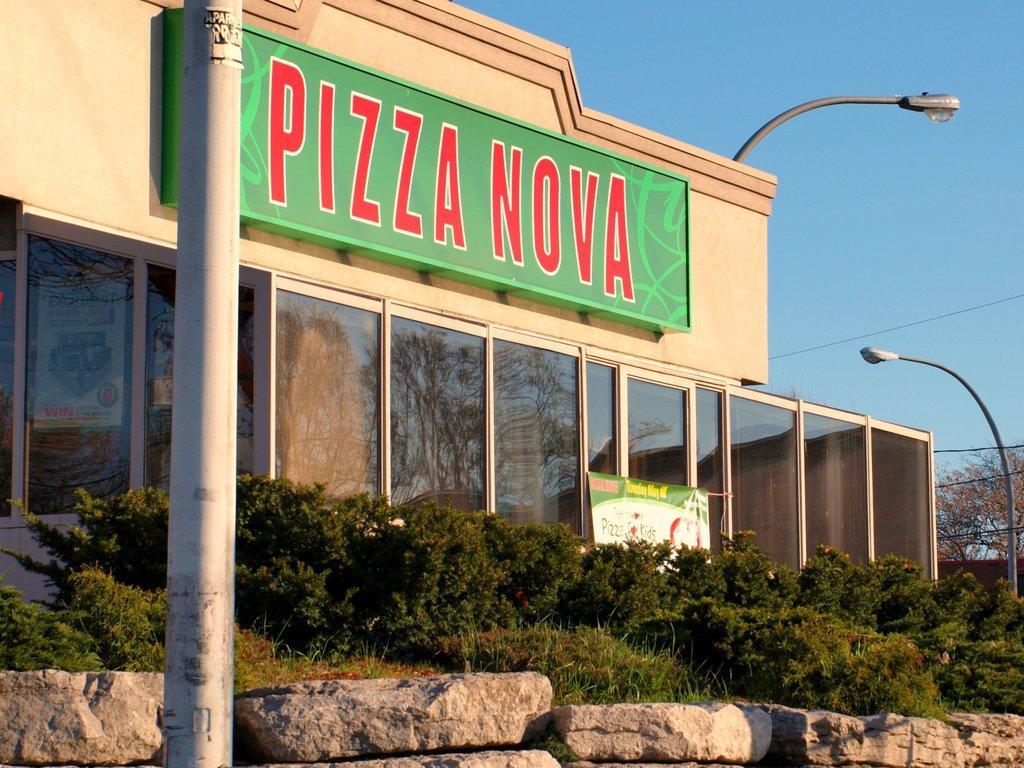In one or two sentences, can you explain what this image depicts? In this image there is a building in the background with some text written on the wall of the building. In front of the building there are plants, there are poles and there is a wall. 